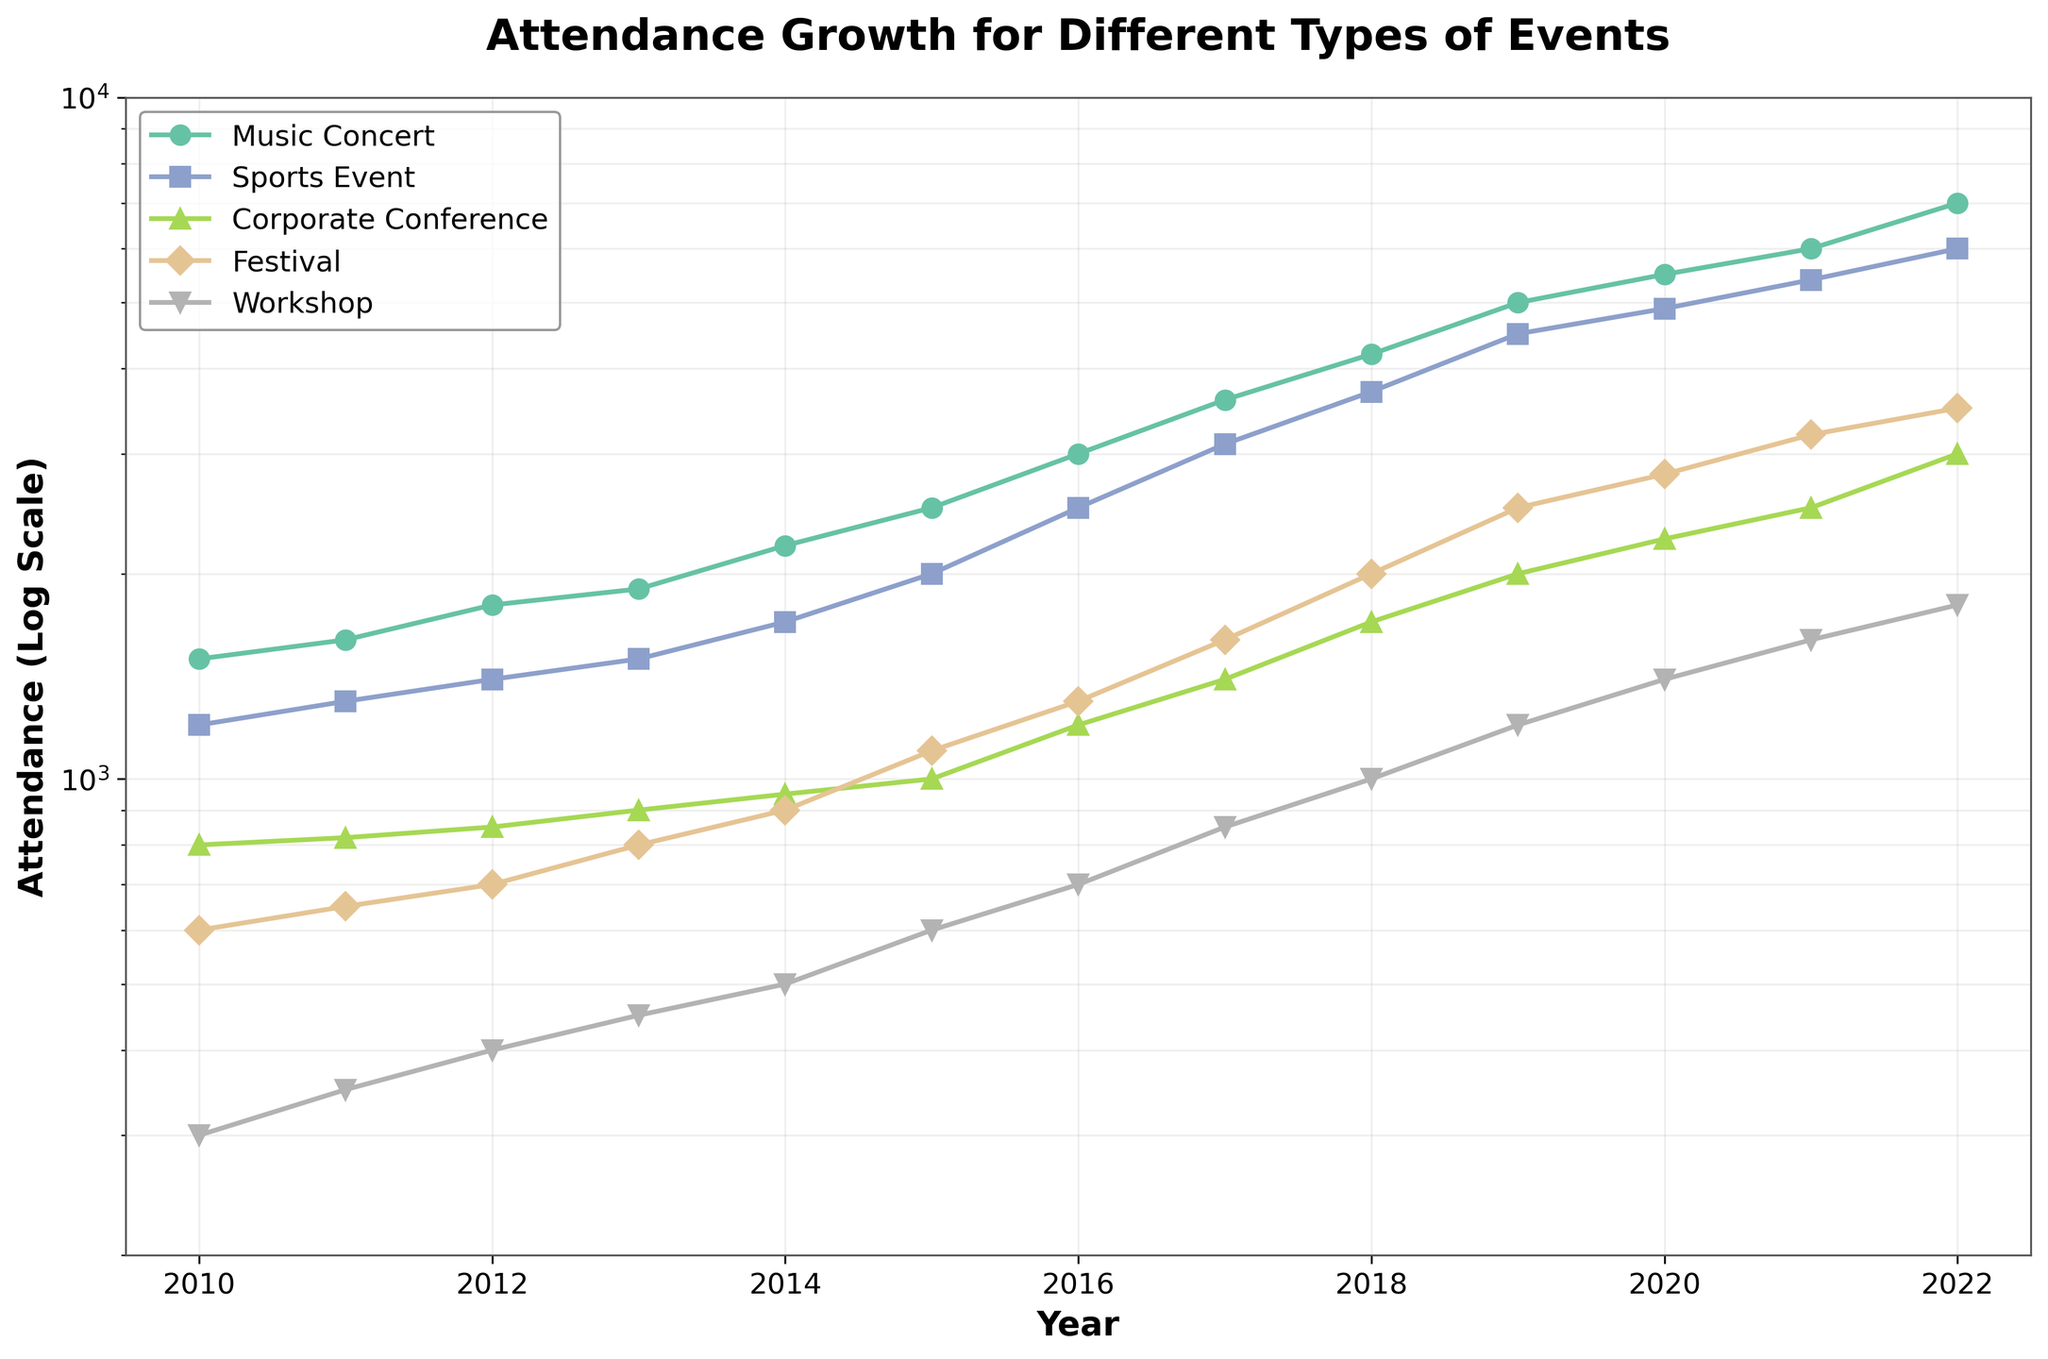Which event type saw the highest attendance in 2022? Look at the endpoint for 2022 in the line representing each event type. The highest point is for Music Concert with an attendance of 7000.
Answer: Music Concert How did attendance for Workshops change from 2010 to 2022? Identify the points for Workshop in 2010 and 2022. In 2010, attendance was 300, and in 2022, it was 1800. Calculate the change by subtracting the initial value from the final value (1800 - 300).
Answer: Increased by 1500 Which event type had the smallest growth in attendance from 2010 to 2022? Compare the initial and final attendance values for all event types. Corporate Conference had the smallest rise from 800 in 2010 to 3000 in 2022, a growth of 2200.
Answer: Corporate Conference What trend do you observe in attendance for Festivals over the years? Observe the line representing Festivals from 2010 to 2022. It increases consistently, indicating a steady growth in attendance each year.
Answer: Increasing trend Between which two consecutive years did Music Concerts see the largest increase in attendance? Check the increments in the Music Concert line. The biggest jump appears from 2017 (3600) to 2018 (4200). Calculate the difference (4200 - 3600 = 600).
Answer: 2017 to 2018 How does the growth of Sports Events compare to Corporate Conferences over the entire period? Compare the lines for Sports Events and Corporate Conferences from 2010 to 2022. Sports Events increased from 1200 to 6000, and Corporate Conferences from 800 to 3000. Sports Events had a higher overall growth.
Answer: Sports Events grew more Which event type had the least attendance in any year? Find the lowest points across all lines. Workshops in 2010 had the least attendance with 300.
Answer: Workshops in 2010 What is the percentage increase in attendance for Festivals from 2010 to 2022? Calculate the initial and final attendance values for Festivals as 600 and 3500. Use the formula ((final - initial) / initial) * 100. Percentage increase = ((3500 - 600) / 600) * 100 = 483.33%.
Answer: 483.33% Is the attendance growth for Workshops exponential or linear? Analyze the Workshop line in the log scale plot. Since a linear appearance in a log scale plot corresponds to exponential growth in the original scale, Workshops show exponential growth.
Answer: Exponential 